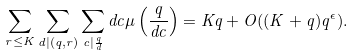Convert formula to latex. <formula><loc_0><loc_0><loc_500><loc_500>\sum _ { r \leq K } \sum _ { d | ( q , r ) } \sum _ { c | \frac { q } { d } } d c \mu \left ( \frac { q } { d c } \right ) = K q + O ( ( K + q ) q ^ { \epsilon } ) .</formula> 